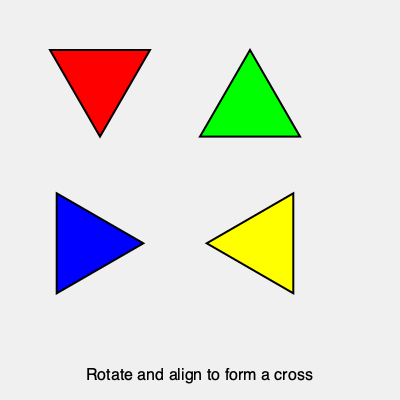In the stained glass window design shown above, how many triangular pieces need to be rotated to form a complete cross pattern? To solve this problem, let's analyze the current position of each triangular piece and determine which ones need to be rotated:

1. The red triangle in the top-left is already in the correct position to form the top of the cross.

2. The green triangle in the top-right is upside-down. It needs to be rotated 180° to form the right arm of the cross.

3. The blue triangle in the bottom-left is rotated 90° clockwise from its correct position. It needs to be rotated 90° counterclockwise to form the left arm of the cross.

4. The yellow triangle in the bottom-right is rotated 90° counterclockwise from its correct position. It needs to be rotated 90° clockwise to form the bottom of the cross.

In total, three triangular pieces (green, blue, and yellow) need to be rotated to form the complete cross pattern in the stained glass window design.

This question relates to the persona of a Greek Catholic priest with an appreciation for church architecture and artistic styles, as it involves the formation of a cross using stained glass, a common feature in many churches.
Answer: 3 